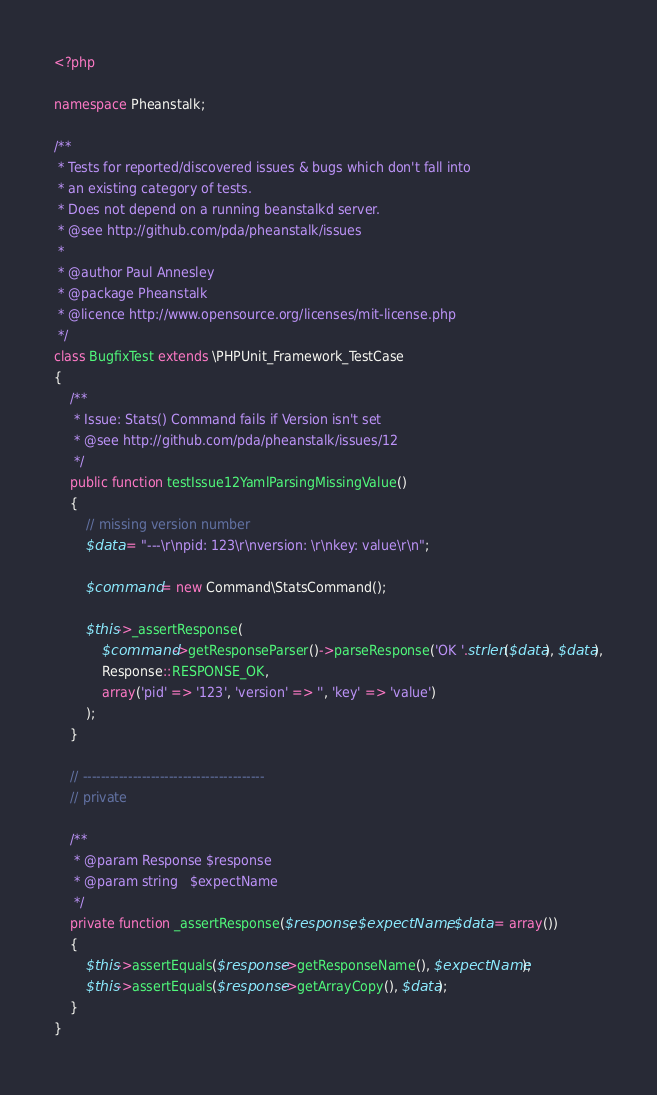Convert code to text. <code><loc_0><loc_0><loc_500><loc_500><_PHP_><?php

namespace Pheanstalk;

/**
 * Tests for reported/discovered issues & bugs which don't fall into
 * an existing category of tests.
 * Does not depend on a running beanstalkd server.
 * @see http://github.com/pda/pheanstalk/issues
 *
 * @author Paul Annesley
 * @package Pheanstalk
 * @licence http://www.opensource.org/licenses/mit-license.php
 */
class BugfixTest extends \PHPUnit_Framework_TestCase
{
    /**
     * Issue: Stats() Command fails if Version isn't set
     * @see http://github.com/pda/pheanstalk/issues/12
     */
    public function testIssue12YamlParsingMissingValue()
    {
        // missing version number
        $data = "---\r\npid: 123\r\nversion: \r\nkey: value\r\n";

        $command = new Command\StatsCommand();

        $this->_assertResponse(
            $command->getResponseParser()->parseResponse('OK '.strlen($data), $data),
            Response::RESPONSE_OK,
            array('pid' => '123', 'version' => '', 'key' => 'value')
        );
    }

    // ----------------------------------------
    // private

    /**
     * @param Response $response
     * @param string   $expectName
     */
    private function _assertResponse($response, $expectName, $data = array())
    {
        $this->assertEquals($response->getResponseName(), $expectName);
        $this->assertEquals($response->getArrayCopy(), $data);
    }
}
</code> 